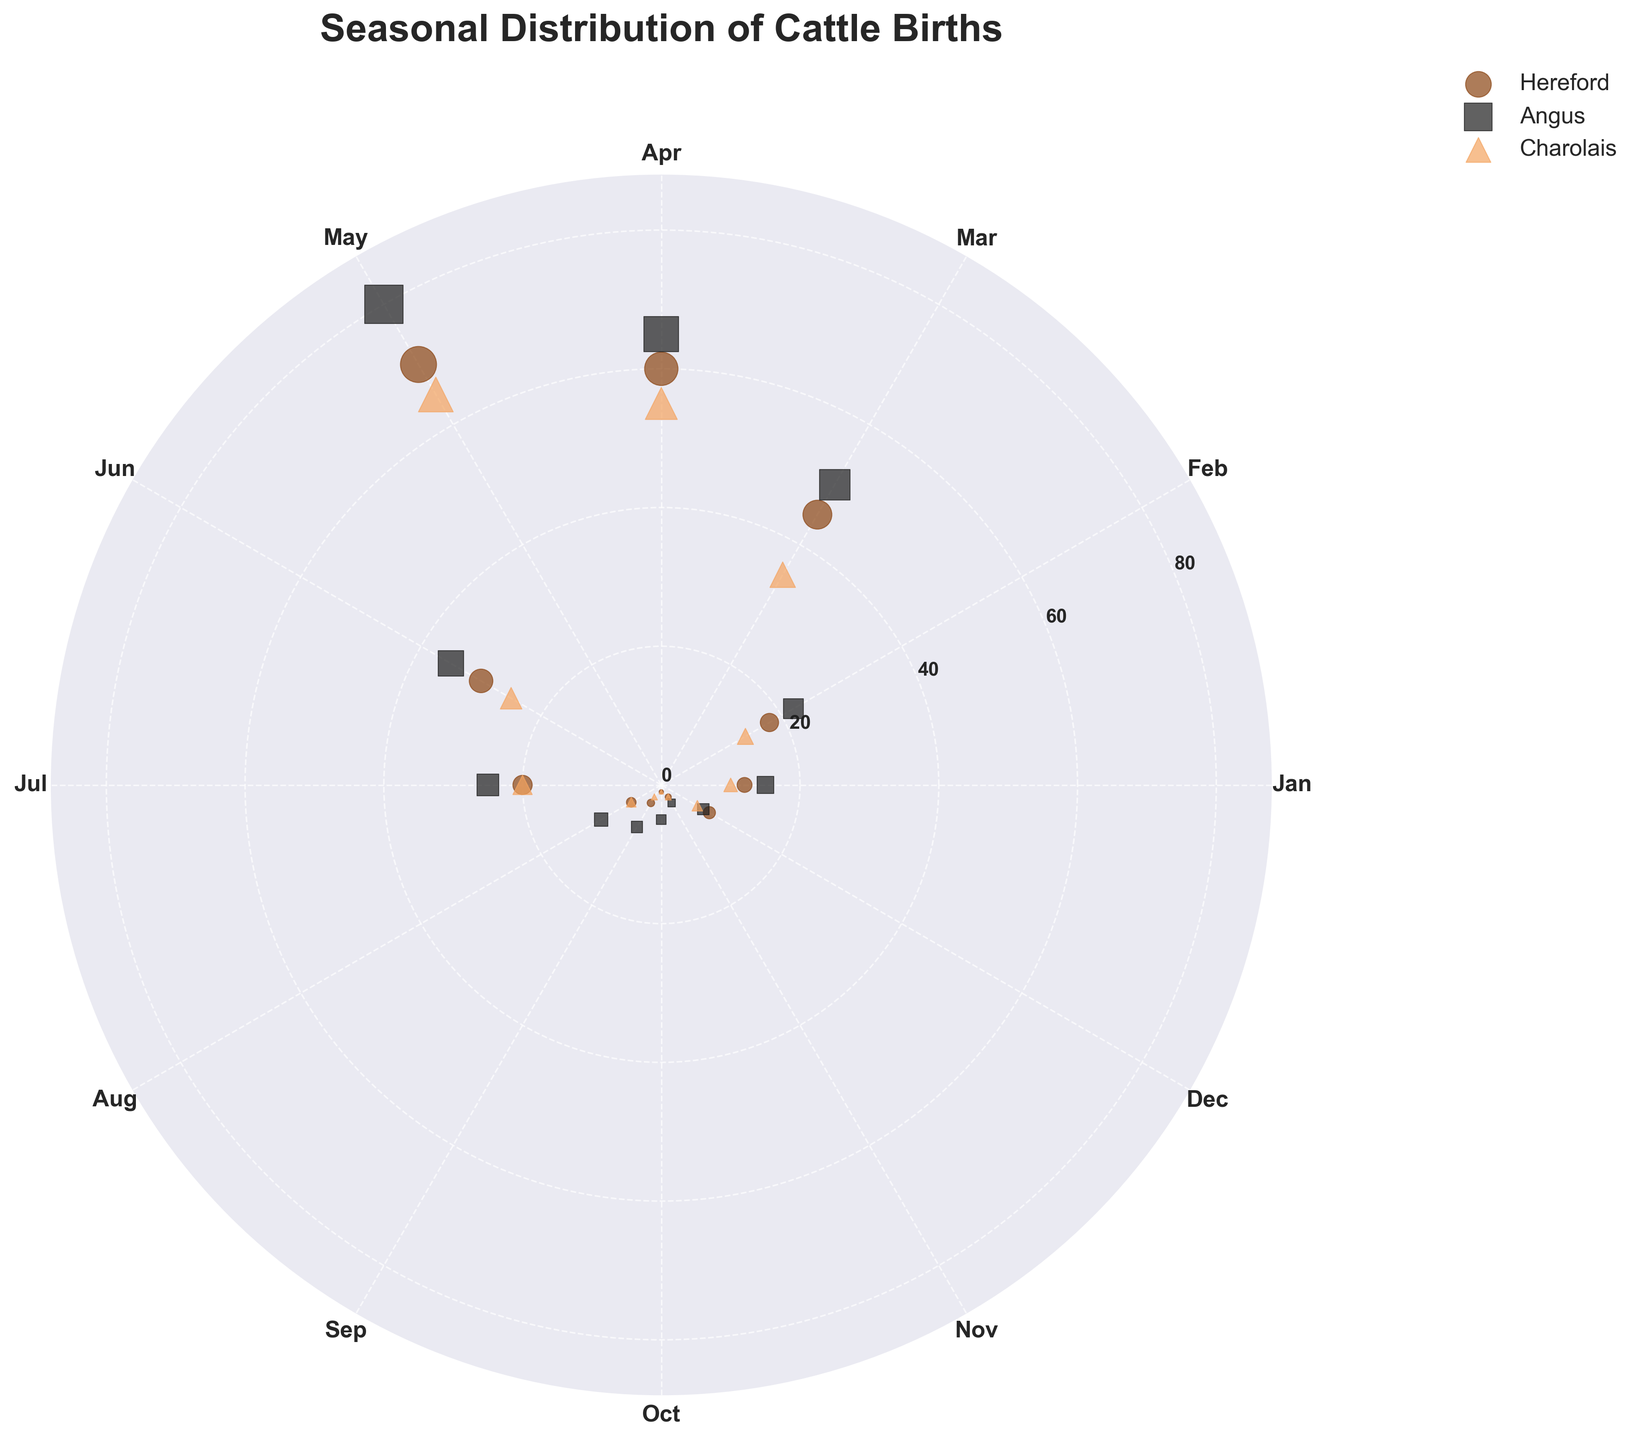Which month sees the highest number of Hereford cattle births? By looking at the radial distance for Hereford cattle in each month, May shows the longest distance from the center, indicating May has the highest number of Hereford births.
Answer: May Which type of cattle has the highest birth number in March? Compare the radial distance for each type of cattle in March. Angus has the longest distance, indicating the highest number of births in March.
Answer: Angus During which months do all types of cattle have less than 10 births? Look for months where all types of cattle do not go far from the center. August, September, October, and November meet this condition.
Answer: August, September, October, November What is the average number of births for Charolais cattle in May and June? Add the number of births for Charolais in May (65) and June (25), and divide by 2. (65 + 25) / 2 = 45
Answer: 45 Which month has the largest disparity in birth rates between Hereford and Charolais cattle? Observe the differences in radial distances between Hereford and Charolais. April shows a large disparity with Hereford having 60 births and Charolais having 55 births.
Answer: April What is the median number of births for Angus cattle throughout the year? List the number of births for Angus: [15, 22, 50, 65, 80, 35, 25, 10, 7, 5, 3, 7]. Sort and find the middle values since there are 12 data points: (22 + 25) / 2 = 23.5
Answer: 23.5 In which month are cattle births the lowest for all types combined? Sum the cattle births across all types for each month. The month with the lowest total births is October with Hereford (1), Angus (5), and Charolais (1). Total = 7.
Answer: October Compare the number of births for each type of cattle in January. Which type has the fewest births? Look at the radial distance in January for each type. Charolais has the shortest distance, indicating the fewest births in January.
Answer: Charolais 